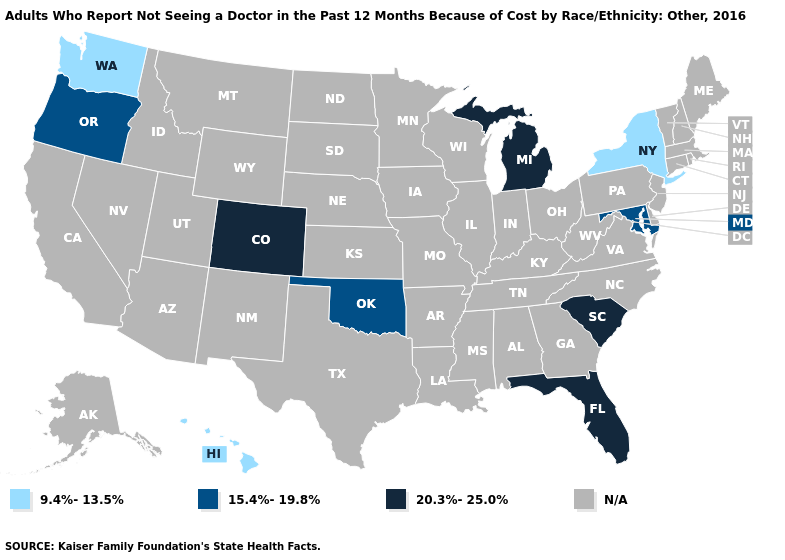Does Colorado have the highest value in the West?
Write a very short answer. Yes. Does Colorado have the highest value in the USA?
Short answer required. Yes. What is the value of Maine?
Quick response, please. N/A. Is the legend a continuous bar?
Write a very short answer. No. Does Maryland have the lowest value in the South?
Short answer required. Yes. Does the first symbol in the legend represent the smallest category?
Concise answer only. Yes. What is the value of Pennsylvania?
Give a very brief answer. N/A. What is the lowest value in the USA?
Be succinct. 9.4%-13.5%. Does Oklahoma have the highest value in the USA?
Be succinct. No. Name the states that have a value in the range 15.4%-19.8%?
Write a very short answer. Maryland, Oklahoma, Oregon. What is the value of Vermont?
Write a very short answer. N/A. Name the states that have a value in the range 9.4%-13.5%?
Answer briefly. Hawaii, New York, Washington. Name the states that have a value in the range 20.3%-25.0%?
Write a very short answer. Colorado, Florida, Michigan, South Carolina. 